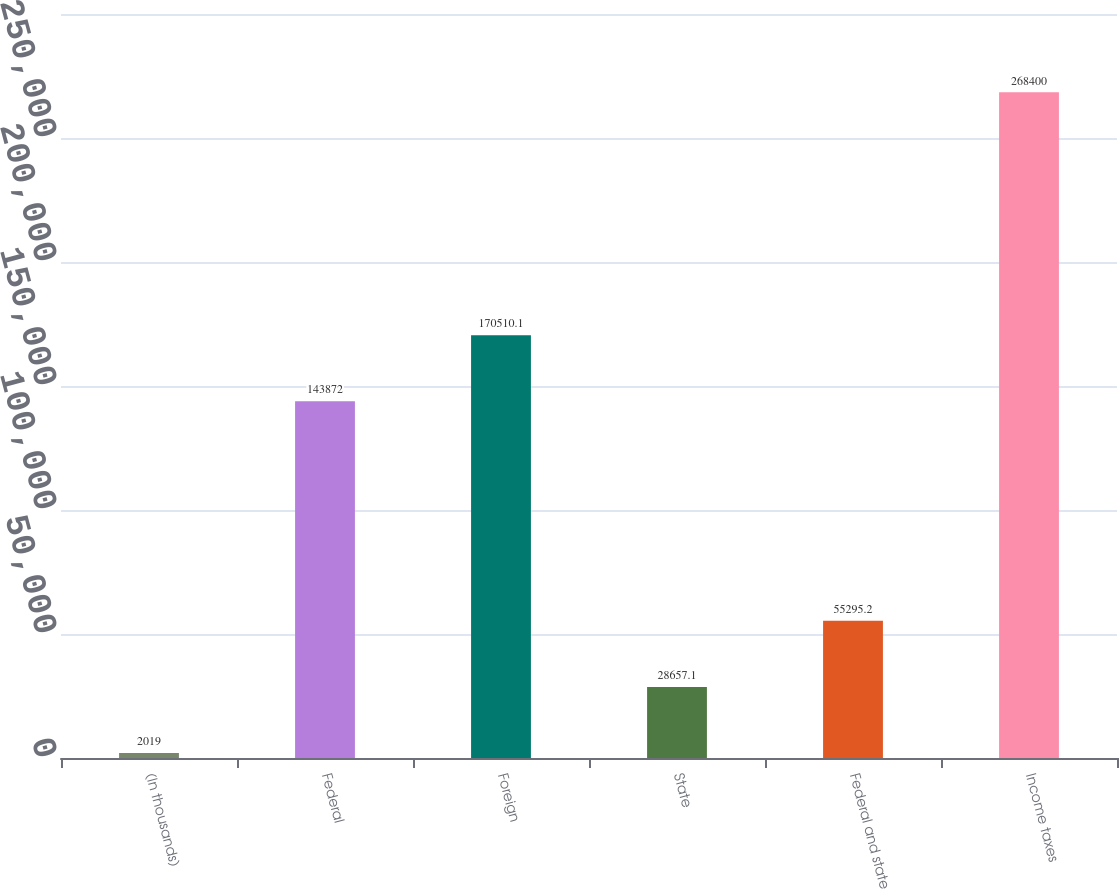<chart> <loc_0><loc_0><loc_500><loc_500><bar_chart><fcel>(In thousands)<fcel>Federal<fcel>Foreign<fcel>State<fcel>Federal and state<fcel>Income taxes<nl><fcel>2019<fcel>143872<fcel>170510<fcel>28657.1<fcel>55295.2<fcel>268400<nl></chart> 